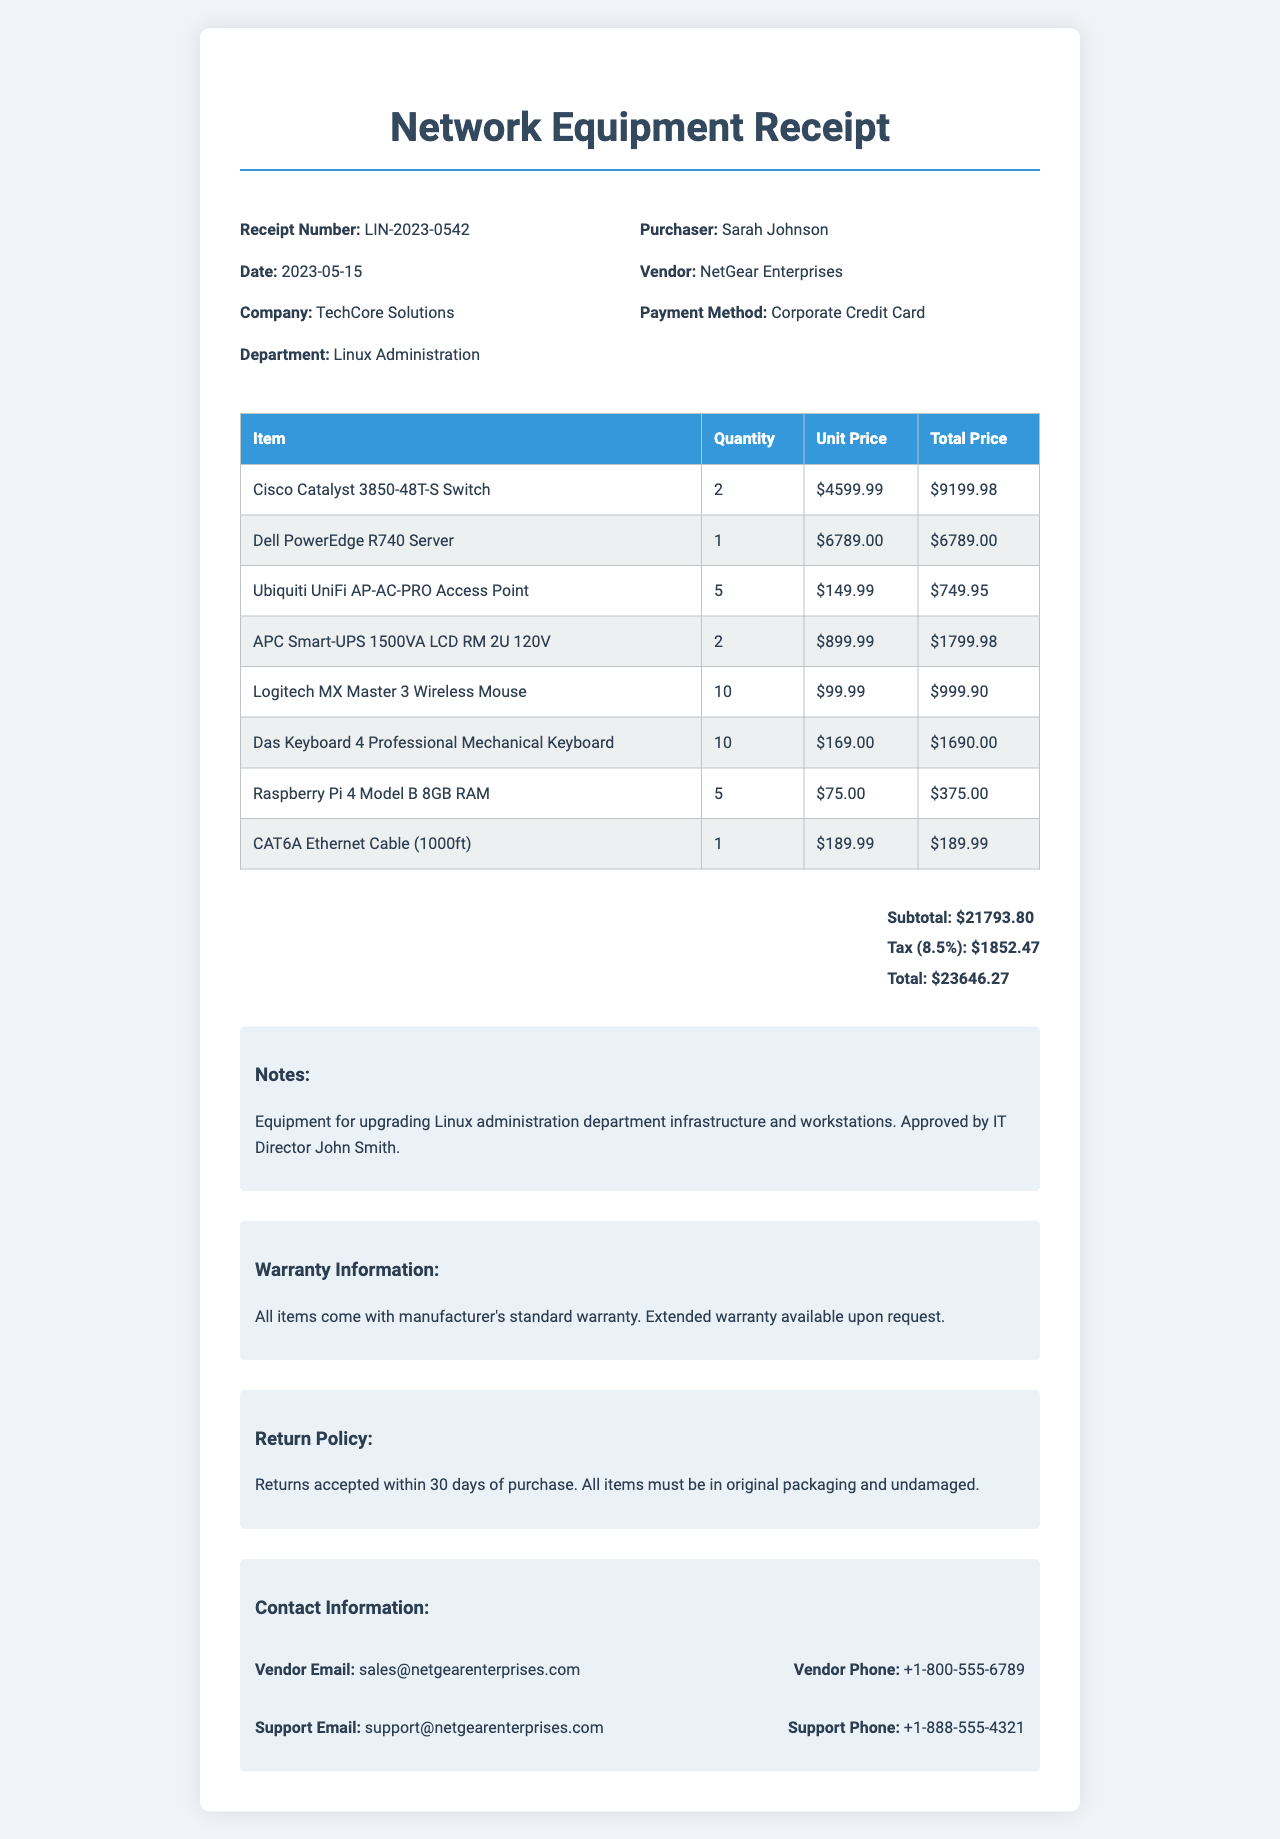what is the receipt number? The receipt number is a unique identifier for the transaction, mentioned clearly in the document.
Answer: LIN-2023-0542 who is the purchaser of the items? The purchaser's name is specified in the document, indicating who made the purchase.
Answer: Sarah Johnson what is the total amount on the receipt? The total amount is the final sum including tax, calculated from the subtotal and tax amount provided in the document.
Answer: 23646.27 how many Logitech MX Master 3 Wireless Mouses were purchased? The quantity of a specific item is listed clearly in the itemized section of the document.
Answer: 10 what is the tax rate applied to the receipt? The tax rate is mentioned in the document as a percentage applied to the subtotal.
Answer: 8.5% what is the return policy for the purchased items? The return policy provides information about conditions for returning products, which is stated in the document.
Answer: Returns accepted within 30 days what is the warranty information provided? The warranty information outlines the standard warranty provisions offered for the purchased items.
Answer: All items come with manufacturer's standard warranty who approved the purchase? The document notes who authorized the transaction, providing context for the purchase's legitimacy.
Answer: IT Director John Smith 